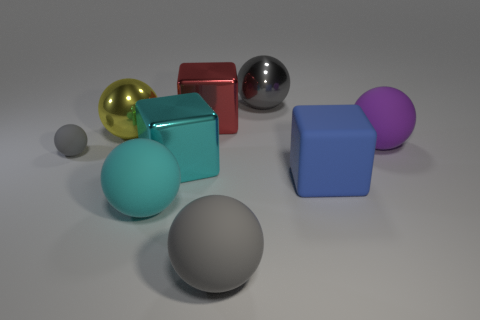Subtract all blue cubes. How many gray spheres are left? 3 Subtract all large matte blocks. How many blocks are left? 2 Subtract all purple balls. How many balls are left? 5 Add 1 large yellow objects. How many objects exist? 10 Subtract all balls. How many objects are left? 3 Subtract all brown cubes. Subtract all blue cylinders. How many cubes are left? 3 Add 7 tiny gray things. How many tiny gray things are left? 8 Add 2 small yellow matte spheres. How many small yellow matte spheres exist? 2 Subtract 1 blue blocks. How many objects are left? 8 Subtract all large cyan blocks. Subtract all large purple blocks. How many objects are left? 8 